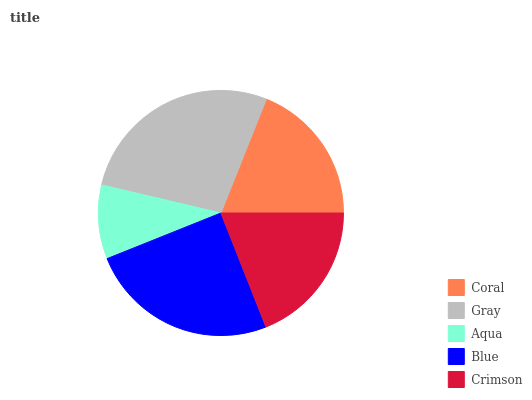Is Aqua the minimum?
Answer yes or no. Yes. Is Gray the maximum?
Answer yes or no. Yes. Is Gray the minimum?
Answer yes or no. No. Is Aqua the maximum?
Answer yes or no. No. Is Gray greater than Aqua?
Answer yes or no. Yes. Is Aqua less than Gray?
Answer yes or no. Yes. Is Aqua greater than Gray?
Answer yes or no. No. Is Gray less than Aqua?
Answer yes or no. No. Is Crimson the high median?
Answer yes or no. Yes. Is Crimson the low median?
Answer yes or no. Yes. Is Coral the high median?
Answer yes or no. No. Is Coral the low median?
Answer yes or no. No. 